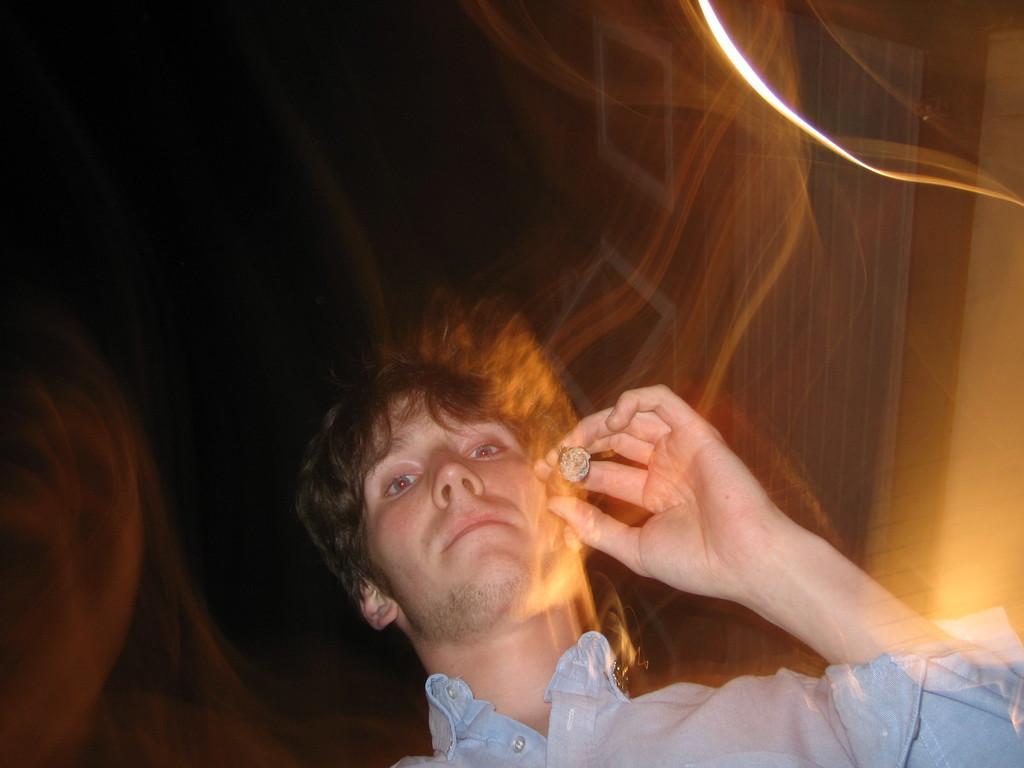How would you summarize this image in a sentence or two? In this picture I can see a man in front, who is wearing a shirt and I see that he is holding a cigar in his hand. In the background I see that it is dark and I see the smoke. 